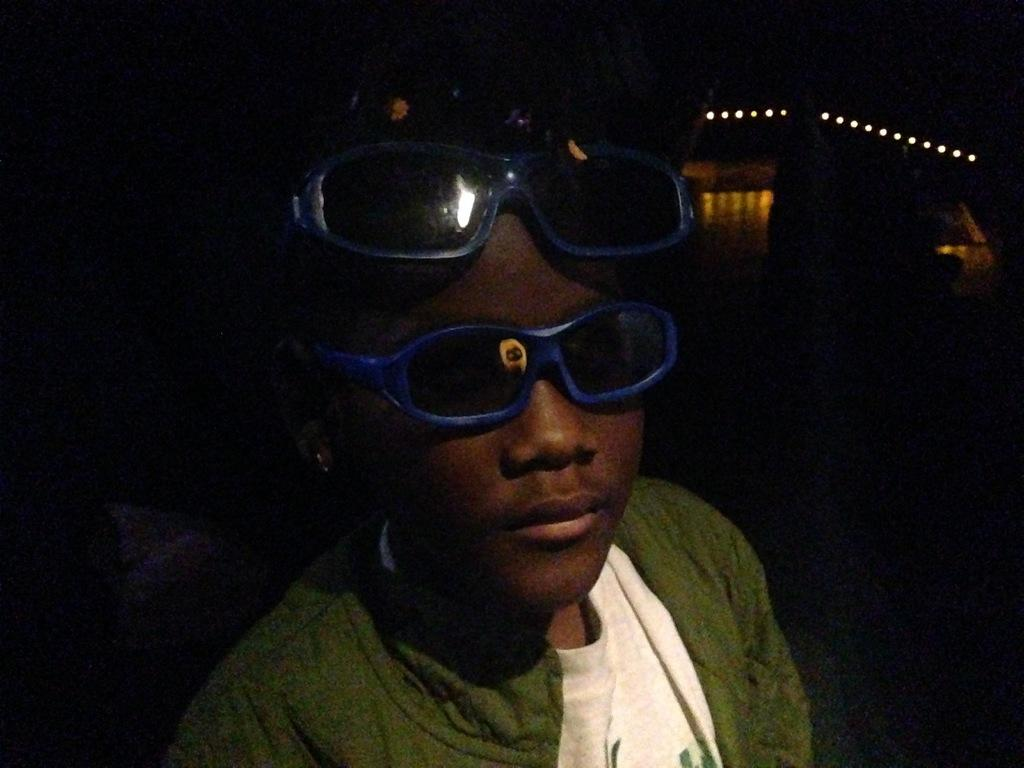Who is present in the image? There is a person in the image. What is the person wearing? The person is wearing goggles. What can be seen in the image besides the person? There are lights visible in the image, as well as some objects. How would you describe the background of the image? The background of the image is dark. What type of relation does the man have with the shelf in the image? There is no man or shelf present in the image. 